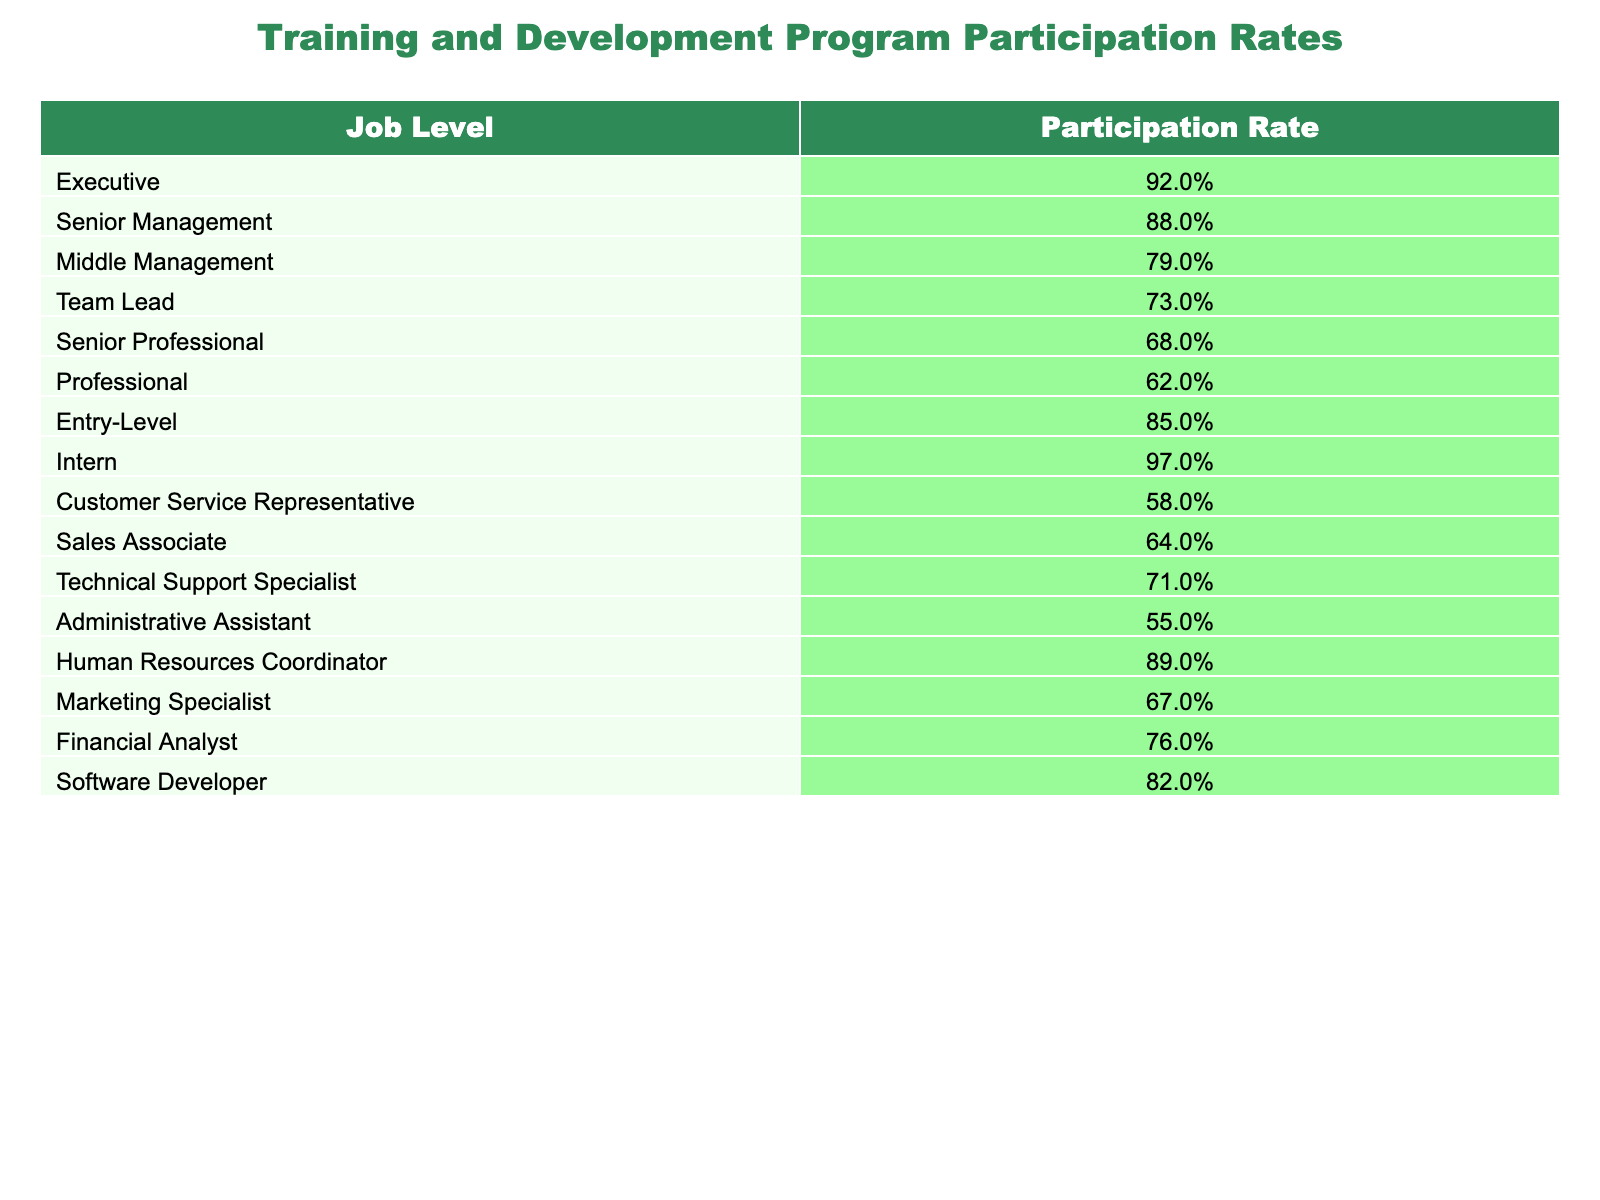What is the participation rate for the Executive job level? The participation rate for the Executive job level can be directly found in the table under 'Participation Rate' corresponding to 'Executive'. It shows 92%.
Answer: 92% Which job level has the lowest participation rate? To find the job level with the lowest participation rate, we compare all the values in the 'Participation Rate' column. 'Administrative Assistant' has the lowest rate at 55%.
Answer: Administrative Assistant What is the average participation rate for the Middle Management and Team Lead job levels? To find the average participation rate, we take the rates for Middle Management (79%) and Team Lead (73%), convert them to decimal (0.79 and 0.73), sum them up (0.79 + 0.73 = 1.52), and then divide by 2. Thus, the average is 1.52 / 2 = 0.76, which is 76%.
Answer: 76% Is the participation rate for Intern higher than that for Customer Service Representative? We compare the participation rates for Intern (97%) and Customer Service Representative (58%). Since 97% is higher than 58%, the statement is true.
Answer: Yes What is the difference in participation rates between the highest and lowest job level? The highest participation rate is for 'Intern' at 97%, and the lowest is for 'Administrative Assistant' at 55%. The difference is calculated by subtracting the lowest from the highest (97% - 55% = 42%).
Answer: 42% Which job level has a participation rate above 80% and what is that rate? We look for job levels with rates above 80%. 'Executive' (92%) and 'Intern' (97%) meet this criterion.
Answer: Executive: 92%, Intern: 97% What percentage of job levels have a participation rate below 70%? In the table, the job levels with participation rates below 70% are 'Customer Service Representative' (58%), 'Sales Associate' (64%), 'Technical Support Specialist' (71%, not below), 'Administrative Assistant' (55%), and 'Senior Professional' (68%, not below). There are 3 job levels below 70% out of 15 total, making it 3/15 = 0.2 or 20%.
Answer: 20% Is the participation rate for Professionals higher than for Sales Associates? Looking at the table, 'Professional' has a participation rate of 62% and 'Sales Associate' has 64%. 62% is not higher than 64%, so the statement is false.
Answer: No If we consider only management levels, what is the average participation rate? The management job levels include Executive (92%), Senior Management (88%), Middle Management (79%), and Team Lead (73%). First, we sum these participation rates: 92% + 88% + 79% + 73% = 332%. Then we divide that sum by the number of management levels (4) to find the average: 332% / 4 = 83%.
Answer: 83% 